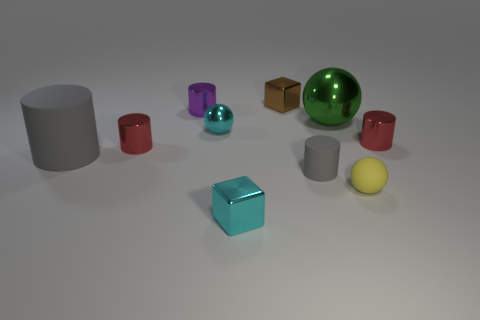What is the material of the tiny gray object that is the same shape as the tiny purple metal object?
Keep it short and to the point. Rubber. There is a thing that is both behind the small matte ball and in front of the big gray cylinder; what is its material?
Make the answer very short. Rubber. What is the size of the green object that is the same material as the brown thing?
Give a very brief answer. Large. What is the shape of the object that is behind the green metal ball and left of the brown object?
Your response must be concise. Cylinder. There is a metallic ball that is on the right side of the tiny shiny block behind the tiny gray cylinder; what size is it?
Offer a very short reply. Large. What number of other objects are there of the same color as the large shiny sphere?
Give a very brief answer. 0. What is the cyan block made of?
Provide a short and direct response. Metal. Are there any big brown matte objects?
Offer a terse response. No. Are there an equal number of large rubber things behind the big metallic ball and big matte cylinders?
Offer a very short reply. No. What number of tiny things are either metal objects or yellow objects?
Provide a succinct answer. 7. 